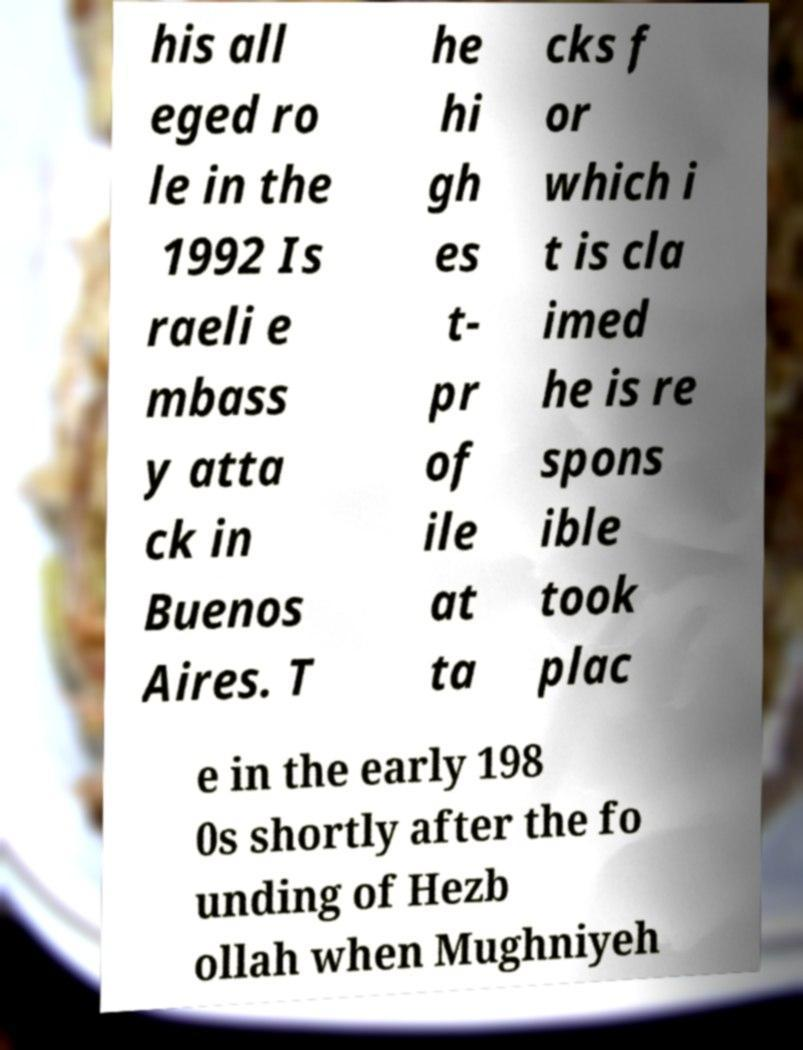Could you extract and type out the text from this image? his all eged ro le in the 1992 Is raeli e mbass y atta ck in Buenos Aires. T he hi gh es t- pr of ile at ta cks f or which i t is cla imed he is re spons ible took plac e in the early 198 0s shortly after the fo unding of Hezb ollah when Mughniyeh 